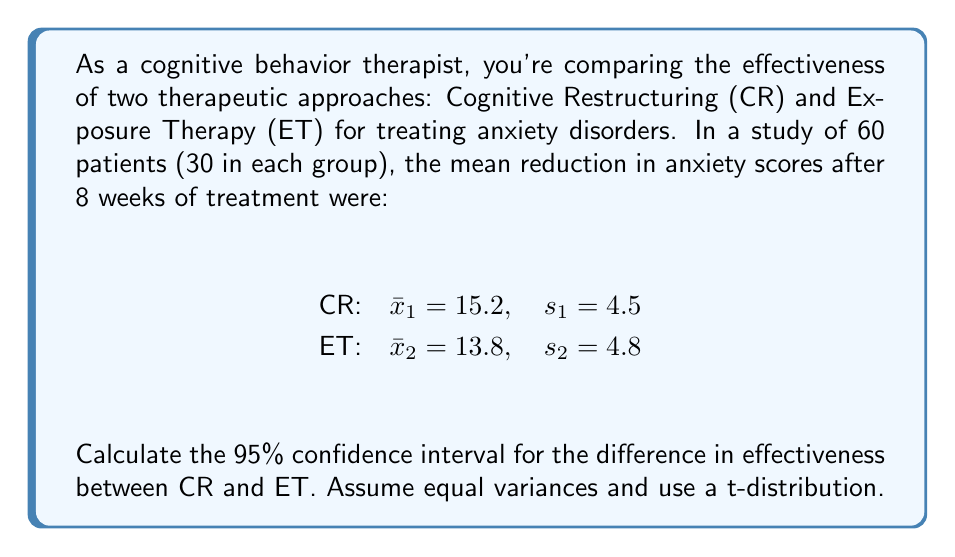Solve this math problem. To calculate the confidence interval for the difference between two means, we'll use the formula:

$$(x̄_1 - x̄_2) \pm t_{\alpha/2} \cdot SE_{x̄_1 - x̄_2}$$

where $SE_{x̄_1 - x̄_2} = \sqrt{\frac{s_p^2}{n_1} + \frac{s_p^2}{n_2}}$ and $s_p^2 = \frac{(n_1-1)s_1^2 + (n_2-1)s_2^2}{n_1 + n_2 - 2}$

Steps:
1. Calculate the pooled variance:
   $$s_p^2 = \frac{(30-1)(4.5)^2 + (30-1)(4.8)^2}{30 + 30 - 2} = 21.7225$$

2. Calculate the standard error:
   $$SE_{x̄_1 - x̄_2} = \sqrt{\frac{21.7225}{30} + \frac{21.7225}{30}} = 1.2024$$

3. Find the t-value for 95% confidence interval with 58 degrees of freedom:
   $t_{0.025, 58} = 2.002$ (from t-distribution table)

4. Calculate the margin of error:
   $$2.002 \cdot 1.2024 = 2.4072$$

5. Calculate the confidence interval:
   $$(15.2 - 13.8) \pm 2.4072$$
   $$1.4 \pm 2.4072$$

6. Final confidence interval:
   $(-1.0072, 3.8072)$
Answer: (-1.0072, 3.8072) 